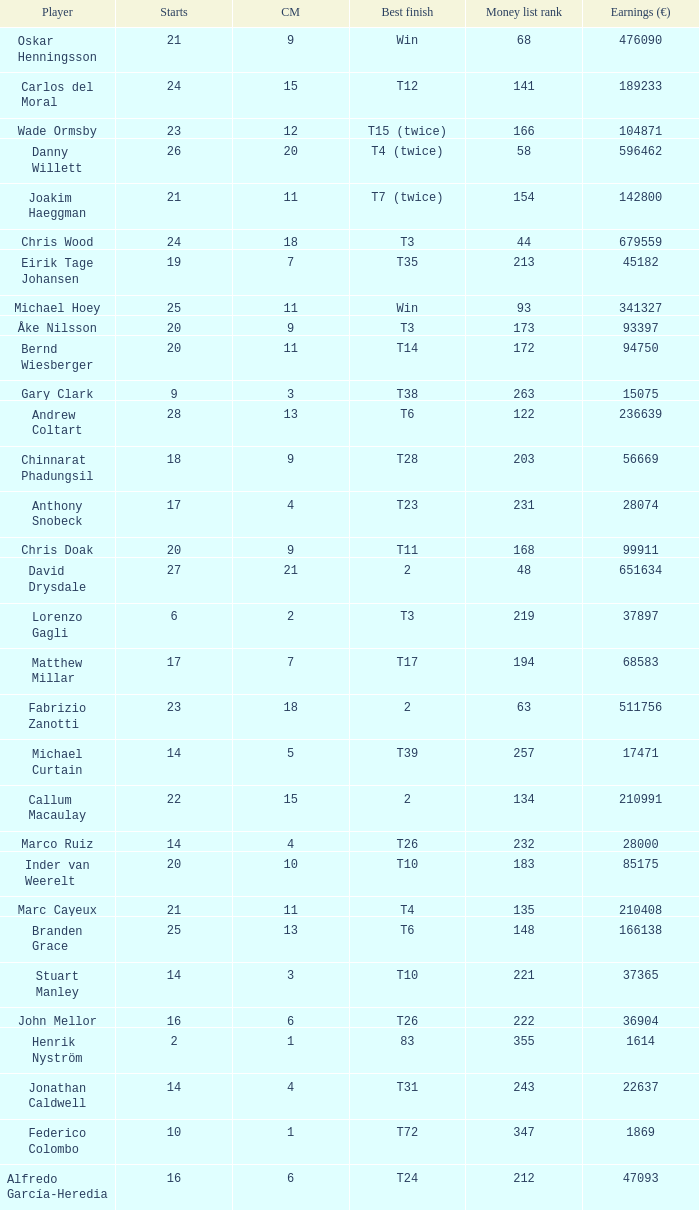How many cuts did Gary Clark make? 3.0. 